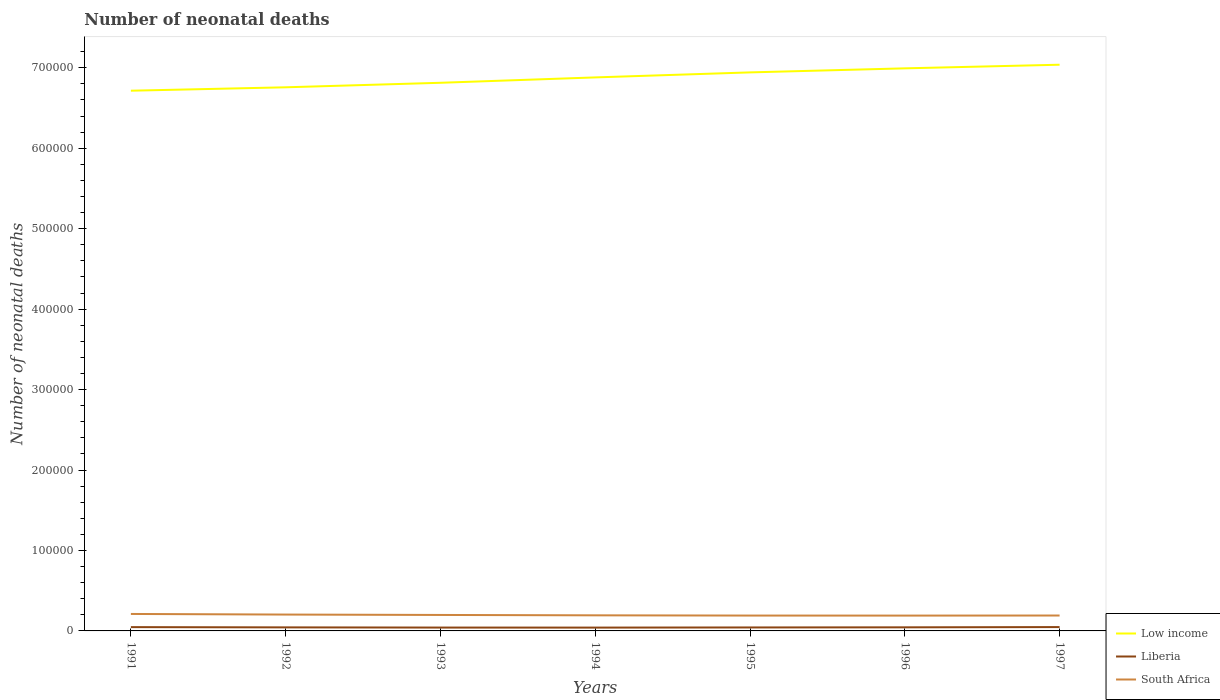Does the line corresponding to South Africa intersect with the line corresponding to Low income?
Ensure brevity in your answer.  No. Across all years, what is the maximum number of neonatal deaths in in Liberia?
Your response must be concise. 4138. What is the total number of neonatal deaths in in South Africa in the graph?
Your answer should be compact. 1247. What is the difference between the highest and the second highest number of neonatal deaths in in Low income?
Your answer should be very brief. 3.23e+04. What is the difference between the highest and the lowest number of neonatal deaths in in South Africa?
Offer a terse response. 3. What is the difference between two consecutive major ticks on the Y-axis?
Provide a short and direct response. 1.00e+05. Are the values on the major ticks of Y-axis written in scientific E-notation?
Provide a succinct answer. No. How many legend labels are there?
Ensure brevity in your answer.  3. How are the legend labels stacked?
Your answer should be very brief. Vertical. What is the title of the graph?
Your answer should be compact. Number of neonatal deaths. What is the label or title of the X-axis?
Your response must be concise. Years. What is the label or title of the Y-axis?
Offer a very short reply. Number of neonatal deaths. What is the Number of neonatal deaths of Low income in 1991?
Offer a terse response. 6.71e+05. What is the Number of neonatal deaths in Liberia in 1991?
Give a very brief answer. 4728. What is the Number of neonatal deaths of South Africa in 1991?
Offer a very short reply. 2.11e+04. What is the Number of neonatal deaths in Low income in 1992?
Your answer should be compact. 6.76e+05. What is the Number of neonatal deaths in Liberia in 1992?
Your response must be concise. 4406. What is the Number of neonatal deaths in South Africa in 1992?
Your answer should be compact. 2.03e+04. What is the Number of neonatal deaths in Low income in 1993?
Keep it short and to the point. 6.81e+05. What is the Number of neonatal deaths of Liberia in 1993?
Your response must be concise. 4167. What is the Number of neonatal deaths of South Africa in 1993?
Make the answer very short. 1.98e+04. What is the Number of neonatal deaths of Low income in 1994?
Make the answer very short. 6.88e+05. What is the Number of neonatal deaths of Liberia in 1994?
Your answer should be compact. 4138. What is the Number of neonatal deaths in South Africa in 1994?
Your response must be concise. 1.94e+04. What is the Number of neonatal deaths in Low income in 1995?
Make the answer very short. 6.94e+05. What is the Number of neonatal deaths of Liberia in 1995?
Your answer should be very brief. 4319. What is the Number of neonatal deaths in South Africa in 1995?
Your answer should be compact. 1.91e+04. What is the Number of neonatal deaths of Low income in 1996?
Give a very brief answer. 6.99e+05. What is the Number of neonatal deaths of Liberia in 1996?
Ensure brevity in your answer.  4470. What is the Number of neonatal deaths of South Africa in 1996?
Keep it short and to the point. 1.90e+04. What is the Number of neonatal deaths of Low income in 1997?
Your response must be concise. 7.04e+05. What is the Number of neonatal deaths of Liberia in 1997?
Offer a very short reply. 4778. What is the Number of neonatal deaths in South Africa in 1997?
Provide a short and direct response. 1.91e+04. Across all years, what is the maximum Number of neonatal deaths in Low income?
Keep it short and to the point. 7.04e+05. Across all years, what is the maximum Number of neonatal deaths in Liberia?
Offer a terse response. 4778. Across all years, what is the maximum Number of neonatal deaths of South Africa?
Keep it short and to the point. 2.11e+04. Across all years, what is the minimum Number of neonatal deaths of Low income?
Your answer should be compact. 6.71e+05. Across all years, what is the minimum Number of neonatal deaths of Liberia?
Make the answer very short. 4138. Across all years, what is the minimum Number of neonatal deaths of South Africa?
Your answer should be very brief. 1.90e+04. What is the total Number of neonatal deaths of Low income in the graph?
Your answer should be compact. 4.81e+06. What is the total Number of neonatal deaths of Liberia in the graph?
Provide a succinct answer. 3.10e+04. What is the total Number of neonatal deaths in South Africa in the graph?
Your response must be concise. 1.38e+05. What is the difference between the Number of neonatal deaths of Low income in 1991 and that in 1992?
Ensure brevity in your answer.  -4219. What is the difference between the Number of neonatal deaths in Liberia in 1991 and that in 1992?
Give a very brief answer. 322. What is the difference between the Number of neonatal deaths of South Africa in 1991 and that in 1992?
Your response must be concise. 760. What is the difference between the Number of neonatal deaths in Low income in 1991 and that in 1993?
Provide a succinct answer. -9841. What is the difference between the Number of neonatal deaths of Liberia in 1991 and that in 1993?
Keep it short and to the point. 561. What is the difference between the Number of neonatal deaths of South Africa in 1991 and that in 1993?
Provide a short and direct response. 1248. What is the difference between the Number of neonatal deaths of Low income in 1991 and that in 1994?
Your answer should be very brief. -1.65e+04. What is the difference between the Number of neonatal deaths of Liberia in 1991 and that in 1994?
Give a very brief answer. 590. What is the difference between the Number of neonatal deaths in South Africa in 1991 and that in 1994?
Give a very brief answer. 1711. What is the difference between the Number of neonatal deaths in Low income in 1991 and that in 1995?
Ensure brevity in your answer.  -2.28e+04. What is the difference between the Number of neonatal deaths in Liberia in 1991 and that in 1995?
Provide a succinct answer. 409. What is the difference between the Number of neonatal deaths in South Africa in 1991 and that in 1995?
Your response must be concise. 2007. What is the difference between the Number of neonatal deaths of Low income in 1991 and that in 1996?
Provide a short and direct response. -2.78e+04. What is the difference between the Number of neonatal deaths of Liberia in 1991 and that in 1996?
Make the answer very short. 258. What is the difference between the Number of neonatal deaths of South Africa in 1991 and that in 1996?
Your answer should be very brief. 2043. What is the difference between the Number of neonatal deaths of Low income in 1991 and that in 1997?
Offer a very short reply. -3.23e+04. What is the difference between the Number of neonatal deaths in South Africa in 1991 and that in 1997?
Your answer should be very brief. 1943. What is the difference between the Number of neonatal deaths in Low income in 1992 and that in 1993?
Provide a short and direct response. -5622. What is the difference between the Number of neonatal deaths in Liberia in 1992 and that in 1993?
Give a very brief answer. 239. What is the difference between the Number of neonatal deaths in South Africa in 1992 and that in 1993?
Make the answer very short. 488. What is the difference between the Number of neonatal deaths in Low income in 1992 and that in 1994?
Give a very brief answer. -1.23e+04. What is the difference between the Number of neonatal deaths of Liberia in 1992 and that in 1994?
Give a very brief answer. 268. What is the difference between the Number of neonatal deaths in South Africa in 1992 and that in 1994?
Provide a succinct answer. 951. What is the difference between the Number of neonatal deaths of Low income in 1992 and that in 1995?
Your response must be concise. -1.85e+04. What is the difference between the Number of neonatal deaths of Liberia in 1992 and that in 1995?
Ensure brevity in your answer.  87. What is the difference between the Number of neonatal deaths in South Africa in 1992 and that in 1995?
Your answer should be compact. 1247. What is the difference between the Number of neonatal deaths of Low income in 1992 and that in 1996?
Keep it short and to the point. -2.36e+04. What is the difference between the Number of neonatal deaths in Liberia in 1992 and that in 1996?
Your answer should be very brief. -64. What is the difference between the Number of neonatal deaths in South Africa in 1992 and that in 1996?
Your answer should be compact. 1283. What is the difference between the Number of neonatal deaths of Low income in 1992 and that in 1997?
Keep it short and to the point. -2.81e+04. What is the difference between the Number of neonatal deaths in Liberia in 1992 and that in 1997?
Give a very brief answer. -372. What is the difference between the Number of neonatal deaths in South Africa in 1992 and that in 1997?
Your answer should be compact. 1183. What is the difference between the Number of neonatal deaths in Low income in 1993 and that in 1994?
Provide a short and direct response. -6683. What is the difference between the Number of neonatal deaths in South Africa in 1993 and that in 1994?
Provide a succinct answer. 463. What is the difference between the Number of neonatal deaths of Low income in 1993 and that in 1995?
Your response must be concise. -1.29e+04. What is the difference between the Number of neonatal deaths in Liberia in 1993 and that in 1995?
Give a very brief answer. -152. What is the difference between the Number of neonatal deaths in South Africa in 1993 and that in 1995?
Ensure brevity in your answer.  759. What is the difference between the Number of neonatal deaths in Low income in 1993 and that in 1996?
Offer a terse response. -1.79e+04. What is the difference between the Number of neonatal deaths of Liberia in 1993 and that in 1996?
Keep it short and to the point. -303. What is the difference between the Number of neonatal deaths in South Africa in 1993 and that in 1996?
Keep it short and to the point. 795. What is the difference between the Number of neonatal deaths of Low income in 1993 and that in 1997?
Your response must be concise. -2.24e+04. What is the difference between the Number of neonatal deaths of Liberia in 1993 and that in 1997?
Ensure brevity in your answer.  -611. What is the difference between the Number of neonatal deaths of South Africa in 1993 and that in 1997?
Give a very brief answer. 695. What is the difference between the Number of neonatal deaths in Low income in 1994 and that in 1995?
Your response must be concise. -6234. What is the difference between the Number of neonatal deaths of Liberia in 1994 and that in 1995?
Keep it short and to the point. -181. What is the difference between the Number of neonatal deaths of South Africa in 1994 and that in 1995?
Provide a short and direct response. 296. What is the difference between the Number of neonatal deaths of Low income in 1994 and that in 1996?
Offer a terse response. -1.13e+04. What is the difference between the Number of neonatal deaths in Liberia in 1994 and that in 1996?
Ensure brevity in your answer.  -332. What is the difference between the Number of neonatal deaths in South Africa in 1994 and that in 1996?
Provide a short and direct response. 332. What is the difference between the Number of neonatal deaths in Low income in 1994 and that in 1997?
Make the answer very short. -1.58e+04. What is the difference between the Number of neonatal deaths in Liberia in 1994 and that in 1997?
Offer a terse response. -640. What is the difference between the Number of neonatal deaths of South Africa in 1994 and that in 1997?
Ensure brevity in your answer.  232. What is the difference between the Number of neonatal deaths in Low income in 1995 and that in 1996?
Make the answer very short. -5026. What is the difference between the Number of neonatal deaths in Liberia in 1995 and that in 1996?
Provide a short and direct response. -151. What is the difference between the Number of neonatal deaths of Low income in 1995 and that in 1997?
Your answer should be compact. -9532. What is the difference between the Number of neonatal deaths in Liberia in 1995 and that in 1997?
Make the answer very short. -459. What is the difference between the Number of neonatal deaths in South Africa in 1995 and that in 1997?
Provide a succinct answer. -64. What is the difference between the Number of neonatal deaths in Low income in 1996 and that in 1997?
Give a very brief answer. -4506. What is the difference between the Number of neonatal deaths of Liberia in 1996 and that in 1997?
Offer a terse response. -308. What is the difference between the Number of neonatal deaths in South Africa in 1996 and that in 1997?
Give a very brief answer. -100. What is the difference between the Number of neonatal deaths in Low income in 1991 and the Number of neonatal deaths in Liberia in 1992?
Your answer should be compact. 6.67e+05. What is the difference between the Number of neonatal deaths in Low income in 1991 and the Number of neonatal deaths in South Africa in 1992?
Give a very brief answer. 6.51e+05. What is the difference between the Number of neonatal deaths in Liberia in 1991 and the Number of neonatal deaths in South Africa in 1992?
Offer a very short reply. -1.56e+04. What is the difference between the Number of neonatal deaths of Low income in 1991 and the Number of neonatal deaths of Liberia in 1993?
Your answer should be very brief. 6.67e+05. What is the difference between the Number of neonatal deaths in Low income in 1991 and the Number of neonatal deaths in South Africa in 1993?
Offer a very short reply. 6.52e+05. What is the difference between the Number of neonatal deaths in Liberia in 1991 and the Number of neonatal deaths in South Africa in 1993?
Ensure brevity in your answer.  -1.51e+04. What is the difference between the Number of neonatal deaths in Low income in 1991 and the Number of neonatal deaths in Liberia in 1994?
Ensure brevity in your answer.  6.67e+05. What is the difference between the Number of neonatal deaths of Low income in 1991 and the Number of neonatal deaths of South Africa in 1994?
Offer a terse response. 6.52e+05. What is the difference between the Number of neonatal deaths in Liberia in 1991 and the Number of neonatal deaths in South Africa in 1994?
Offer a terse response. -1.46e+04. What is the difference between the Number of neonatal deaths in Low income in 1991 and the Number of neonatal deaths in Liberia in 1995?
Provide a short and direct response. 6.67e+05. What is the difference between the Number of neonatal deaths of Low income in 1991 and the Number of neonatal deaths of South Africa in 1995?
Make the answer very short. 6.52e+05. What is the difference between the Number of neonatal deaths of Liberia in 1991 and the Number of neonatal deaths of South Africa in 1995?
Your answer should be compact. -1.44e+04. What is the difference between the Number of neonatal deaths in Low income in 1991 and the Number of neonatal deaths in Liberia in 1996?
Give a very brief answer. 6.67e+05. What is the difference between the Number of neonatal deaths of Low income in 1991 and the Number of neonatal deaths of South Africa in 1996?
Your response must be concise. 6.52e+05. What is the difference between the Number of neonatal deaths of Liberia in 1991 and the Number of neonatal deaths of South Africa in 1996?
Your response must be concise. -1.43e+04. What is the difference between the Number of neonatal deaths of Low income in 1991 and the Number of neonatal deaths of Liberia in 1997?
Your answer should be very brief. 6.67e+05. What is the difference between the Number of neonatal deaths of Low income in 1991 and the Number of neonatal deaths of South Africa in 1997?
Provide a succinct answer. 6.52e+05. What is the difference between the Number of neonatal deaths in Liberia in 1991 and the Number of neonatal deaths in South Africa in 1997?
Your response must be concise. -1.44e+04. What is the difference between the Number of neonatal deaths of Low income in 1992 and the Number of neonatal deaths of Liberia in 1993?
Ensure brevity in your answer.  6.72e+05. What is the difference between the Number of neonatal deaths of Low income in 1992 and the Number of neonatal deaths of South Africa in 1993?
Ensure brevity in your answer.  6.56e+05. What is the difference between the Number of neonatal deaths in Liberia in 1992 and the Number of neonatal deaths in South Africa in 1993?
Provide a short and direct response. -1.54e+04. What is the difference between the Number of neonatal deaths in Low income in 1992 and the Number of neonatal deaths in Liberia in 1994?
Offer a very short reply. 6.72e+05. What is the difference between the Number of neonatal deaths of Low income in 1992 and the Number of neonatal deaths of South Africa in 1994?
Give a very brief answer. 6.56e+05. What is the difference between the Number of neonatal deaths in Liberia in 1992 and the Number of neonatal deaths in South Africa in 1994?
Provide a short and direct response. -1.50e+04. What is the difference between the Number of neonatal deaths of Low income in 1992 and the Number of neonatal deaths of Liberia in 1995?
Keep it short and to the point. 6.71e+05. What is the difference between the Number of neonatal deaths of Low income in 1992 and the Number of neonatal deaths of South Africa in 1995?
Keep it short and to the point. 6.57e+05. What is the difference between the Number of neonatal deaths of Liberia in 1992 and the Number of neonatal deaths of South Africa in 1995?
Give a very brief answer. -1.47e+04. What is the difference between the Number of neonatal deaths in Low income in 1992 and the Number of neonatal deaths in Liberia in 1996?
Your answer should be compact. 6.71e+05. What is the difference between the Number of neonatal deaths of Low income in 1992 and the Number of neonatal deaths of South Africa in 1996?
Give a very brief answer. 6.57e+05. What is the difference between the Number of neonatal deaths of Liberia in 1992 and the Number of neonatal deaths of South Africa in 1996?
Your answer should be very brief. -1.46e+04. What is the difference between the Number of neonatal deaths of Low income in 1992 and the Number of neonatal deaths of Liberia in 1997?
Offer a terse response. 6.71e+05. What is the difference between the Number of neonatal deaths in Low income in 1992 and the Number of neonatal deaths in South Africa in 1997?
Provide a succinct answer. 6.57e+05. What is the difference between the Number of neonatal deaths in Liberia in 1992 and the Number of neonatal deaths in South Africa in 1997?
Offer a terse response. -1.47e+04. What is the difference between the Number of neonatal deaths in Low income in 1993 and the Number of neonatal deaths in Liberia in 1994?
Offer a very short reply. 6.77e+05. What is the difference between the Number of neonatal deaths of Low income in 1993 and the Number of neonatal deaths of South Africa in 1994?
Provide a succinct answer. 6.62e+05. What is the difference between the Number of neonatal deaths in Liberia in 1993 and the Number of neonatal deaths in South Africa in 1994?
Your response must be concise. -1.52e+04. What is the difference between the Number of neonatal deaths in Low income in 1993 and the Number of neonatal deaths in Liberia in 1995?
Your response must be concise. 6.77e+05. What is the difference between the Number of neonatal deaths in Low income in 1993 and the Number of neonatal deaths in South Africa in 1995?
Your response must be concise. 6.62e+05. What is the difference between the Number of neonatal deaths in Liberia in 1993 and the Number of neonatal deaths in South Africa in 1995?
Make the answer very short. -1.49e+04. What is the difference between the Number of neonatal deaths of Low income in 1993 and the Number of neonatal deaths of Liberia in 1996?
Your response must be concise. 6.77e+05. What is the difference between the Number of neonatal deaths of Low income in 1993 and the Number of neonatal deaths of South Africa in 1996?
Your answer should be very brief. 6.62e+05. What is the difference between the Number of neonatal deaths in Liberia in 1993 and the Number of neonatal deaths in South Africa in 1996?
Provide a short and direct response. -1.49e+04. What is the difference between the Number of neonatal deaths of Low income in 1993 and the Number of neonatal deaths of Liberia in 1997?
Offer a terse response. 6.77e+05. What is the difference between the Number of neonatal deaths in Low income in 1993 and the Number of neonatal deaths in South Africa in 1997?
Offer a very short reply. 6.62e+05. What is the difference between the Number of neonatal deaths in Liberia in 1993 and the Number of neonatal deaths in South Africa in 1997?
Provide a short and direct response. -1.50e+04. What is the difference between the Number of neonatal deaths in Low income in 1994 and the Number of neonatal deaths in Liberia in 1995?
Offer a very short reply. 6.84e+05. What is the difference between the Number of neonatal deaths in Low income in 1994 and the Number of neonatal deaths in South Africa in 1995?
Provide a short and direct response. 6.69e+05. What is the difference between the Number of neonatal deaths in Liberia in 1994 and the Number of neonatal deaths in South Africa in 1995?
Make the answer very short. -1.49e+04. What is the difference between the Number of neonatal deaths in Low income in 1994 and the Number of neonatal deaths in Liberia in 1996?
Ensure brevity in your answer.  6.84e+05. What is the difference between the Number of neonatal deaths in Low income in 1994 and the Number of neonatal deaths in South Africa in 1996?
Make the answer very short. 6.69e+05. What is the difference between the Number of neonatal deaths in Liberia in 1994 and the Number of neonatal deaths in South Africa in 1996?
Provide a short and direct response. -1.49e+04. What is the difference between the Number of neonatal deaths in Low income in 1994 and the Number of neonatal deaths in Liberia in 1997?
Your answer should be compact. 6.83e+05. What is the difference between the Number of neonatal deaths of Low income in 1994 and the Number of neonatal deaths of South Africa in 1997?
Ensure brevity in your answer.  6.69e+05. What is the difference between the Number of neonatal deaths in Liberia in 1994 and the Number of neonatal deaths in South Africa in 1997?
Your answer should be very brief. -1.50e+04. What is the difference between the Number of neonatal deaths in Low income in 1995 and the Number of neonatal deaths in Liberia in 1996?
Make the answer very short. 6.90e+05. What is the difference between the Number of neonatal deaths of Low income in 1995 and the Number of neonatal deaths of South Africa in 1996?
Make the answer very short. 6.75e+05. What is the difference between the Number of neonatal deaths of Liberia in 1995 and the Number of neonatal deaths of South Africa in 1996?
Ensure brevity in your answer.  -1.47e+04. What is the difference between the Number of neonatal deaths in Low income in 1995 and the Number of neonatal deaths in Liberia in 1997?
Make the answer very short. 6.89e+05. What is the difference between the Number of neonatal deaths in Low income in 1995 and the Number of neonatal deaths in South Africa in 1997?
Your answer should be very brief. 6.75e+05. What is the difference between the Number of neonatal deaths in Liberia in 1995 and the Number of neonatal deaths in South Africa in 1997?
Ensure brevity in your answer.  -1.48e+04. What is the difference between the Number of neonatal deaths in Low income in 1996 and the Number of neonatal deaths in Liberia in 1997?
Offer a very short reply. 6.94e+05. What is the difference between the Number of neonatal deaths in Low income in 1996 and the Number of neonatal deaths in South Africa in 1997?
Give a very brief answer. 6.80e+05. What is the difference between the Number of neonatal deaths in Liberia in 1996 and the Number of neonatal deaths in South Africa in 1997?
Make the answer very short. -1.47e+04. What is the average Number of neonatal deaths in Low income per year?
Provide a short and direct response. 6.88e+05. What is the average Number of neonatal deaths of Liberia per year?
Your answer should be compact. 4429.43. What is the average Number of neonatal deaths in South Africa per year?
Your answer should be very brief. 1.97e+04. In the year 1991, what is the difference between the Number of neonatal deaths in Low income and Number of neonatal deaths in Liberia?
Provide a succinct answer. 6.67e+05. In the year 1991, what is the difference between the Number of neonatal deaths in Low income and Number of neonatal deaths in South Africa?
Your answer should be very brief. 6.50e+05. In the year 1991, what is the difference between the Number of neonatal deaths of Liberia and Number of neonatal deaths of South Africa?
Offer a terse response. -1.64e+04. In the year 1992, what is the difference between the Number of neonatal deaths in Low income and Number of neonatal deaths in Liberia?
Give a very brief answer. 6.71e+05. In the year 1992, what is the difference between the Number of neonatal deaths of Low income and Number of neonatal deaths of South Africa?
Your answer should be compact. 6.55e+05. In the year 1992, what is the difference between the Number of neonatal deaths of Liberia and Number of neonatal deaths of South Africa?
Make the answer very short. -1.59e+04. In the year 1993, what is the difference between the Number of neonatal deaths in Low income and Number of neonatal deaths in Liberia?
Offer a terse response. 6.77e+05. In the year 1993, what is the difference between the Number of neonatal deaths of Low income and Number of neonatal deaths of South Africa?
Provide a short and direct response. 6.61e+05. In the year 1993, what is the difference between the Number of neonatal deaths in Liberia and Number of neonatal deaths in South Africa?
Your answer should be very brief. -1.57e+04. In the year 1994, what is the difference between the Number of neonatal deaths of Low income and Number of neonatal deaths of Liberia?
Ensure brevity in your answer.  6.84e+05. In the year 1994, what is the difference between the Number of neonatal deaths of Low income and Number of neonatal deaths of South Africa?
Your response must be concise. 6.69e+05. In the year 1994, what is the difference between the Number of neonatal deaths in Liberia and Number of neonatal deaths in South Africa?
Keep it short and to the point. -1.52e+04. In the year 1995, what is the difference between the Number of neonatal deaths in Low income and Number of neonatal deaths in Liberia?
Your response must be concise. 6.90e+05. In the year 1995, what is the difference between the Number of neonatal deaths of Low income and Number of neonatal deaths of South Africa?
Make the answer very short. 6.75e+05. In the year 1995, what is the difference between the Number of neonatal deaths in Liberia and Number of neonatal deaths in South Africa?
Your answer should be compact. -1.48e+04. In the year 1996, what is the difference between the Number of neonatal deaths in Low income and Number of neonatal deaths in Liberia?
Your answer should be compact. 6.95e+05. In the year 1996, what is the difference between the Number of neonatal deaths in Low income and Number of neonatal deaths in South Africa?
Your answer should be compact. 6.80e+05. In the year 1996, what is the difference between the Number of neonatal deaths of Liberia and Number of neonatal deaths of South Africa?
Make the answer very short. -1.46e+04. In the year 1997, what is the difference between the Number of neonatal deaths in Low income and Number of neonatal deaths in Liberia?
Your answer should be very brief. 6.99e+05. In the year 1997, what is the difference between the Number of neonatal deaths of Low income and Number of neonatal deaths of South Africa?
Make the answer very short. 6.85e+05. In the year 1997, what is the difference between the Number of neonatal deaths of Liberia and Number of neonatal deaths of South Africa?
Provide a succinct answer. -1.44e+04. What is the ratio of the Number of neonatal deaths in Liberia in 1991 to that in 1992?
Your response must be concise. 1.07. What is the ratio of the Number of neonatal deaths in South Africa in 1991 to that in 1992?
Offer a terse response. 1.04. What is the ratio of the Number of neonatal deaths of Low income in 1991 to that in 1993?
Ensure brevity in your answer.  0.99. What is the ratio of the Number of neonatal deaths in Liberia in 1991 to that in 1993?
Give a very brief answer. 1.13. What is the ratio of the Number of neonatal deaths of South Africa in 1991 to that in 1993?
Offer a very short reply. 1.06. What is the ratio of the Number of neonatal deaths of Low income in 1991 to that in 1994?
Give a very brief answer. 0.98. What is the ratio of the Number of neonatal deaths of Liberia in 1991 to that in 1994?
Your answer should be very brief. 1.14. What is the ratio of the Number of neonatal deaths in South Africa in 1991 to that in 1994?
Provide a succinct answer. 1.09. What is the ratio of the Number of neonatal deaths in Low income in 1991 to that in 1995?
Your response must be concise. 0.97. What is the ratio of the Number of neonatal deaths of Liberia in 1991 to that in 1995?
Your answer should be compact. 1.09. What is the ratio of the Number of neonatal deaths of South Africa in 1991 to that in 1995?
Offer a terse response. 1.11. What is the ratio of the Number of neonatal deaths in Low income in 1991 to that in 1996?
Your response must be concise. 0.96. What is the ratio of the Number of neonatal deaths in Liberia in 1991 to that in 1996?
Provide a short and direct response. 1.06. What is the ratio of the Number of neonatal deaths in South Africa in 1991 to that in 1996?
Give a very brief answer. 1.11. What is the ratio of the Number of neonatal deaths of Low income in 1991 to that in 1997?
Give a very brief answer. 0.95. What is the ratio of the Number of neonatal deaths of Liberia in 1991 to that in 1997?
Provide a succinct answer. 0.99. What is the ratio of the Number of neonatal deaths of South Africa in 1991 to that in 1997?
Your answer should be very brief. 1.1. What is the ratio of the Number of neonatal deaths in Liberia in 1992 to that in 1993?
Keep it short and to the point. 1.06. What is the ratio of the Number of neonatal deaths of South Africa in 1992 to that in 1993?
Keep it short and to the point. 1.02. What is the ratio of the Number of neonatal deaths of Low income in 1992 to that in 1994?
Your answer should be compact. 0.98. What is the ratio of the Number of neonatal deaths in Liberia in 1992 to that in 1994?
Provide a succinct answer. 1.06. What is the ratio of the Number of neonatal deaths in South Africa in 1992 to that in 1994?
Offer a terse response. 1.05. What is the ratio of the Number of neonatal deaths of Low income in 1992 to that in 1995?
Provide a succinct answer. 0.97. What is the ratio of the Number of neonatal deaths in Liberia in 1992 to that in 1995?
Ensure brevity in your answer.  1.02. What is the ratio of the Number of neonatal deaths in South Africa in 1992 to that in 1995?
Provide a short and direct response. 1.07. What is the ratio of the Number of neonatal deaths in Low income in 1992 to that in 1996?
Your response must be concise. 0.97. What is the ratio of the Number of neonatal deaths in Liberia in 1992 to that in 1996?
Your response must be concise. 0.99. What is the ratio of the Number of neonatal deaths of South Africa in 1992 to that in 1996?
Provide a succinct answer. 1.07. What is the ratio of the Number of neonatal deaths of Low income in 1992 to that in 1997?
Your answer should be compact. 0.96. What is the ratio of the Number of neonatal deaths in Liberia in 1992 to that in 1997?
Your answer should be very brief. 0.92. What is the ratio of the Number of neonatal deaths in South Africa in 1992 to that in 1997?
Offer a very short reply. 1.06. What is the ratio of the Number of neonatal deaths in Low income in 1993 to that in 1994?
Offer a very short reply. 0.99. What is the ratio of the Number of neonatal deaths of Liberia in 1993 to that in 1994?
Your answer should be very brief. 1.01. What is the ratio of the Number of neonatal deaths in South Africa in 1993 to that in 1994?
Keep it short and to the point. 1.02. What is the ratio of the Number of neonatal deaths of Low income in 1993 to that in 1995?
Your answer should be very brief. 0.98. What is the ratio of the Number of neonatal deaths of Liberia in 1993 to that in 1995?
Give a very brief answer. 0.96. What is the ratio of the Number of neonatal deaths of South Africa in 1993 to that in 1995?
Keep it short and to the point. 1.04. What is the ratio of the Number of neonatal deaths of Low income in 1993 to that in 1996?
Make the answer very short. 0.97. What is the ratio of the Number of neonatal deaths in Liberia in 1993 to that in 1996?
Offer a very short reply. 0.93. What is the ratio of the Number of neonatal deaths of South Africa in 1993 to that in 1996?
Ensure brevity in your answer.  1.04. What is the ratio of the Number of neonatal deaths in Low income in 1993 to that in 1997?
Provide a succinct answer. 0.97. What is the ratio of the Number of neonatal deaths in Liberia in 1993 to that in 1997?
Your answer should be compact. 0.87. What is the ratio of the Number of neonatal deaths of South Africa in 1993 to that in 1997?
Offer a very short reply. 1.04. What is the ratio of the Number of neonatal deaths in Liberia in 1994 to that in 1995?
Your response must be concise. 0.96. What is the ratio of the Number of neonatal deaths of South Africa in 1994 to that in 1995?
Provide a succinct answer. 1.02. What is the ratio of the Number of neonatal deaths in Low income in 1994 to that in 1996?
Your answer should be compact. 0.98. What is the ratio of the Number of neonatal deaths of Liberia in 1994 to that in 1996?
Keep it short and to the point. 0.93. What is the ratio of the Number of neonatal deaths of South Africa in 1994 to that in 1996?
Make the answer very short. 1.02. What is the ratio of the Number of neonatal deaths in Low income in 1994 to that in 1997?
Your answer should be very brief. 0.98. What is the ratio of the Number of neonatal deaths in Liberia in 1994 to that in 1997?
Offer a terse response. 0.87. What is the ratio of the Number of neonatal deaths of South Africa in 1994 to that in 1997?
Keep it short and to the point. 1.01. What is the ratio of the Number of neonatal deaths of Liberia in 1995 to that in 1996?
Provide a succinct answer. 0.97. What is the ratio of the Number of neonatal deaths of Low income in 1995 to that in 1997?
Your answer should be very brief. 0.99. What is the ratio of the Number of neonatal deaths in Liberia in 1995 to that in 1997?
Give a very brief answer. 0.9. What is the ratio of the Number of neonatal deaths of Liberia in 1996 to that in 1997?
Give a very brief answer. 0.94. What is the ratio of the Number of neonatal deaths in South Africa in 1996 to that in 1997?
Keep it short and to the point. 0.99. What is the difference between the highest and the second highest Number of neonatal deaths in Low income?
Offer a very short reply. 4506. What is the difference between the highest and the second highest Number of neonatal deaths of South Africa?
Your answer should be very brief. 760. What is the difference between the highest and the lowest Number of neonatal deaths in Low income?
Ensure brevity in your answer.  3.23e+04. What is the difference between the highest and the lowest Number of neonatal deaths in Liberia?
Ensure brevity in your answer.  640. What is the difference between the highest and the lowest Number of neonatal deaths in South Africa?
Offer a terse response. 2043. 